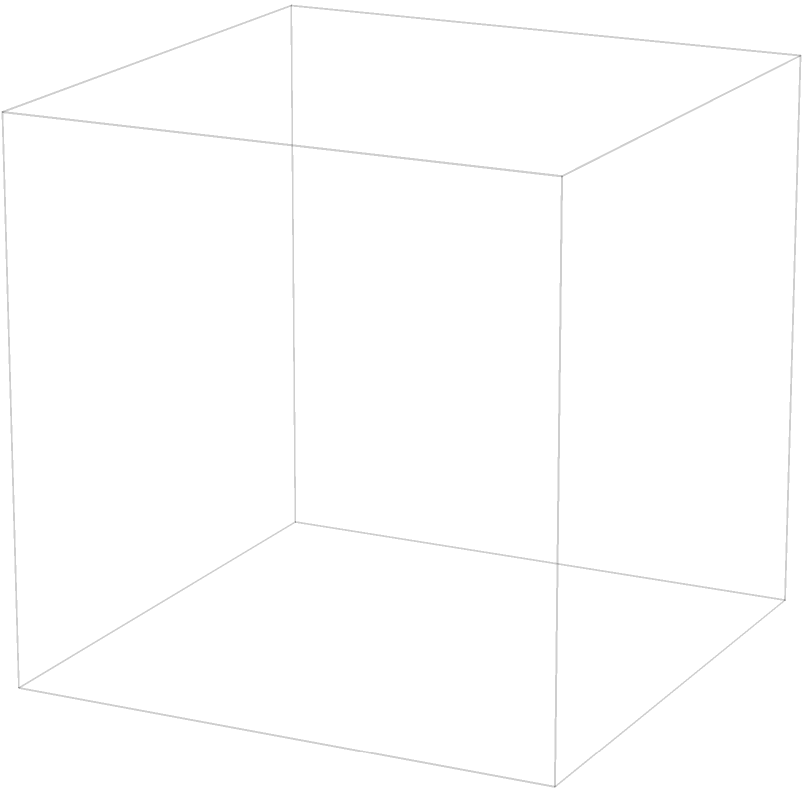Two geological fault planes intersect as shown in the diagram. Fault 1 is defined by the equation $x + z = 1$, and Fault 2 is defined by $y + z = 1$. A valuable mineral deposit is located along the line of intersection between these two faults. What is the equation of this line of intersection, and how might this information impact mining operations and potential environmental concerns? To solve this problem, we'll follow these steps:

1) First, we need to find the equation of the line of intersection between the two fault planes.

2) The equations of the fault planes are:
   Fault 1: $x + z = 1$
   Fault 2: $y + z = 1$

3) To find the intersection, we need to solve these equations simultaneously:
   $x + z = 1$ ... (1)
   $y + z = 1$ ... (2)

4) Subtracting equation (2) from equation (1):
   $x - y = 0$
   $x = y$

5) Substituting this back into either of the original equations, let's use (1):
   $y + z = 1$

6) So, the line of intersection is defined by:
   $x = y$
   $y + z = 1$

7) This can be written parametrically as:
   $x = t$
   $y = t$
   $z = 1 - t$
   where $t$ is a parameter that varies from 0 to 1.

8) This line goes from point A (0,0,1) to point B (1,1,0) in the cube.

9) Impact on mining operations:
   - The mineral deposit is concentrated along this line, so mining operations should focus on this specific path.
   - This could lead to more precise and potentially less destructive mining techniques.

10) Environmental concerns:
    - Focusing on a narrow line might reduce the overall area impacted by mining.
    - However, the intersection of two fault planes could indicate an area of geological instability, potentially increasing the risk of induced seismicity from mining activities.
    - The geologist might need to balance the economic benefits of accessing this concentrated deposit against the potential environmental risks of operating in a geologically complex area.
Answer: Line of intersection: $x = y, z = 1 - x$ (or parametrically, $x = t, y = t, z = 1 - t$). This allows focused mining but raises concerns about geological stability and potential environmental impacts. 